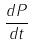<formula> <loc_0><loc_0><loc_500><loc_500>\frac { d P } { d t }</formula> 